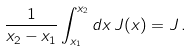<formula> <loc_0><loc_0><loc_500><loc_500>\frac { 1 } { x _ { 2 } - x _ { 1 } } \int _ { x _ { 1 } } ^ { x _ { 2 } } d x \, J ( x ) = J \, .</formula> 